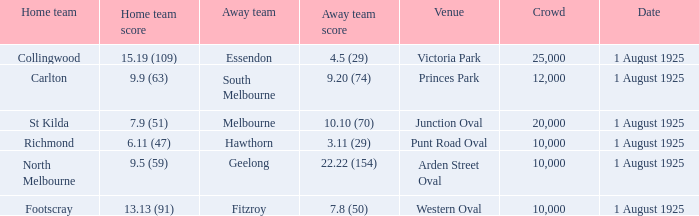When did the match take place that had a home team score of 7.9 (51)? 1 August 1925. 